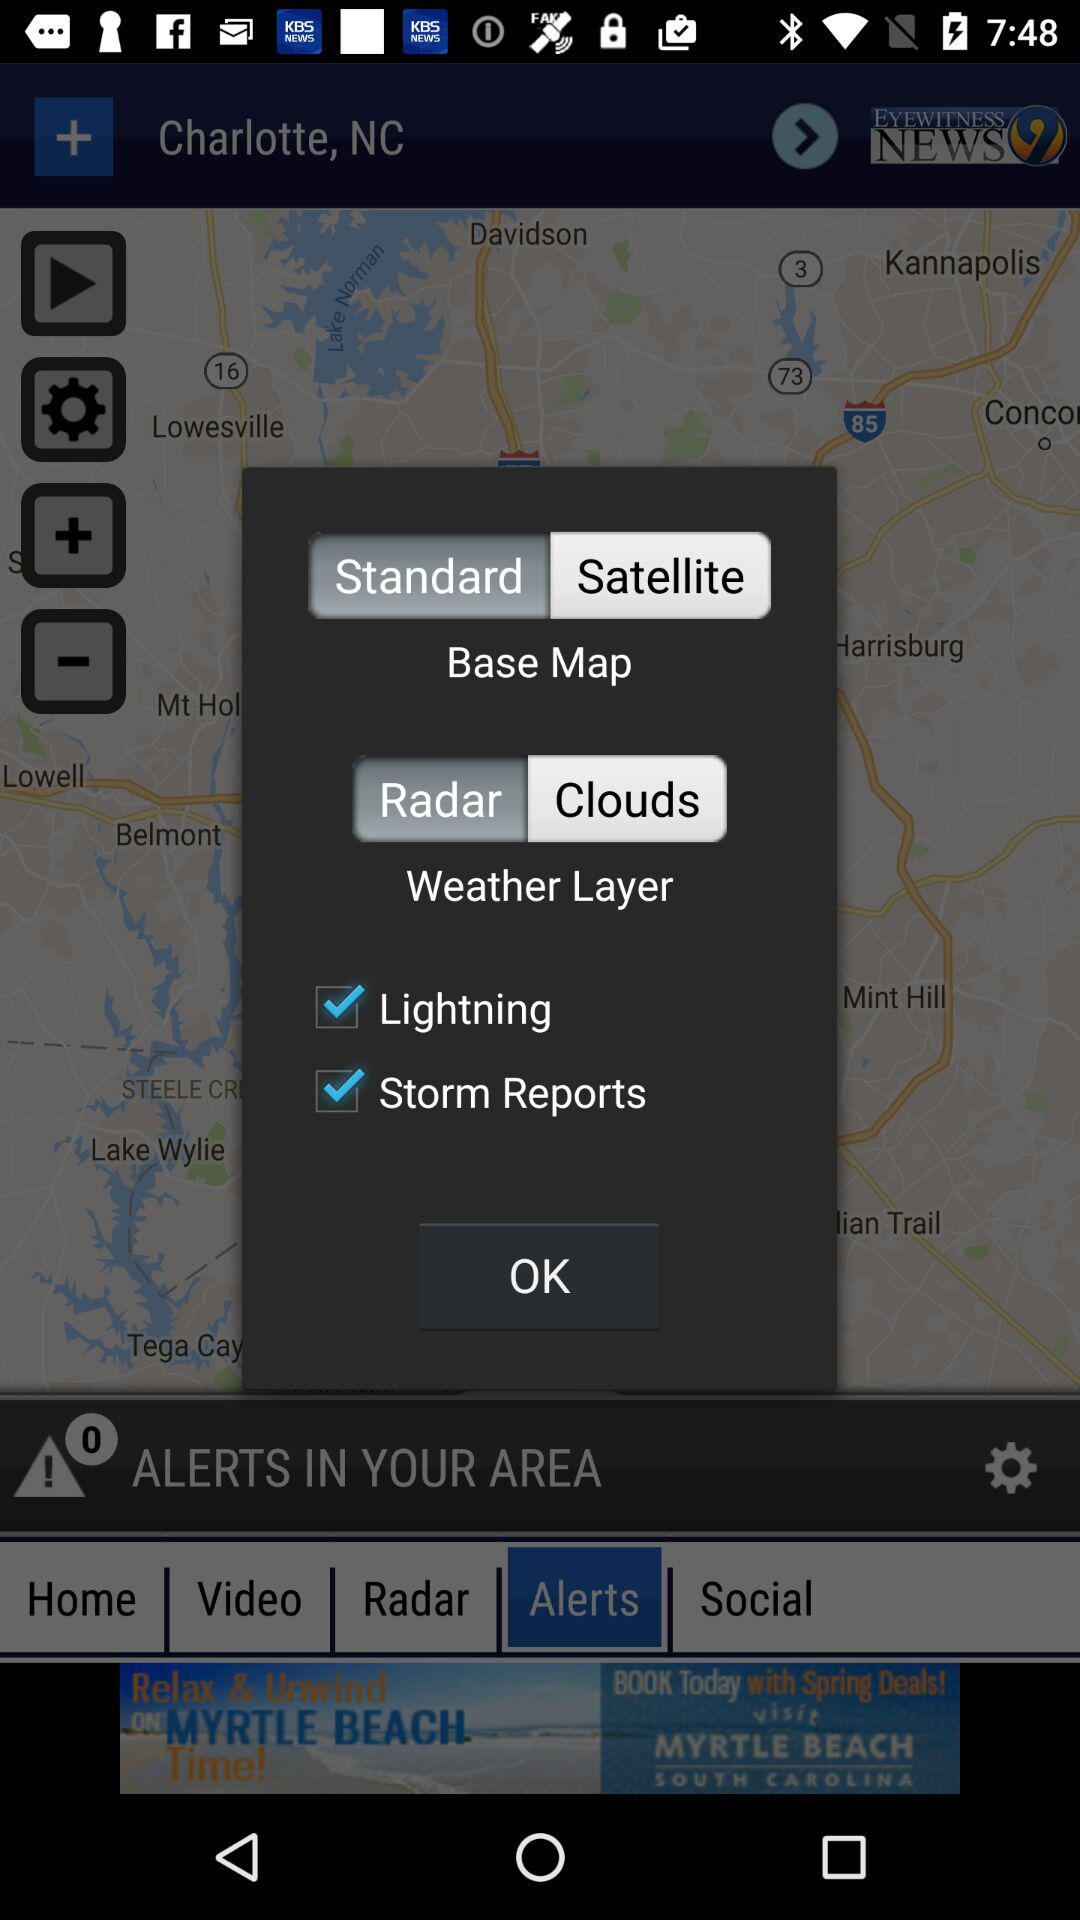How many layers are available?
Answer the question using a single word or phrase. 2 